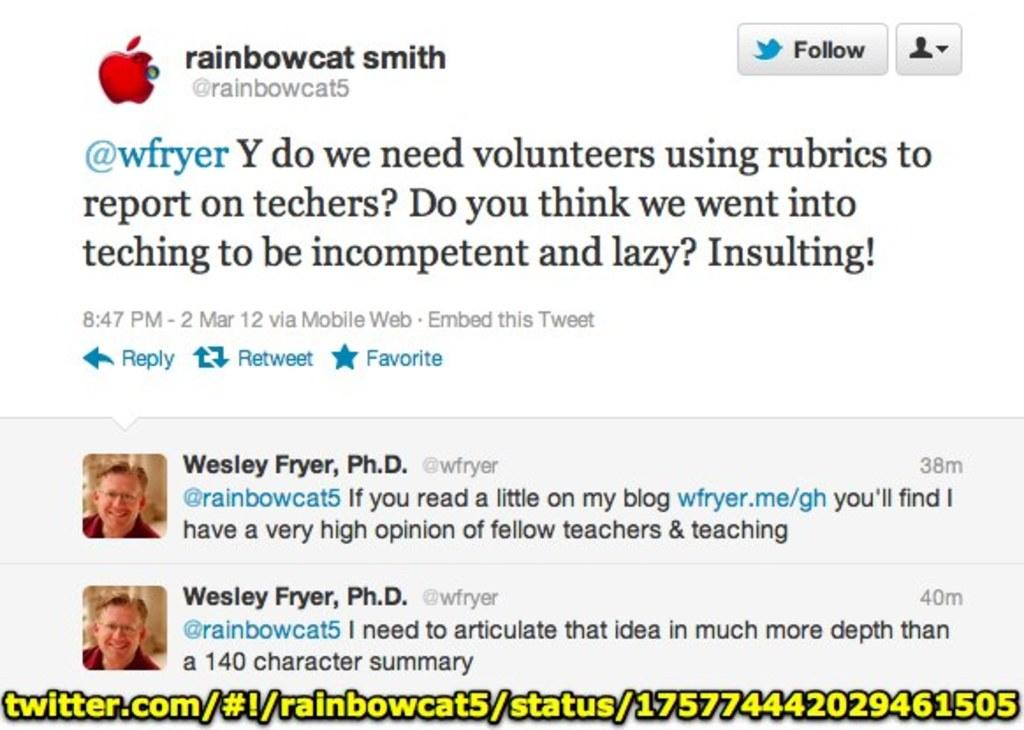What type of content is shown in the image? The image contains a screenshot. What can be seen within the screenshot? There is text visible in the screenshot, as well as a person's photo on the left side. What company's symbol is present in the screenshot? The Apple symbol is present in the screenshot. What type of lipstick is the mother wearing in the image? There is no mother or lipstick present in the image; it contains a screenshot with text, a person's photo, and the Apple symbol. What kind of mark can be seen on the person's face in the image? There is no mark visible on the person's face in the image; only their photo is present. 